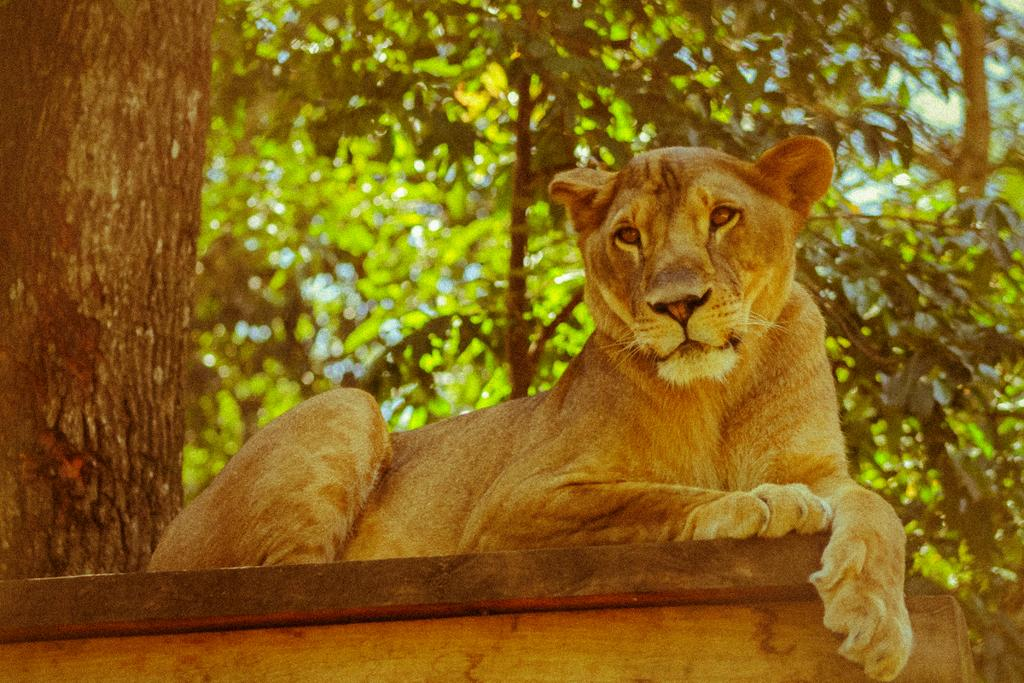What animal is the main subject of the image? There is a lion in the image. Where is the lion located in the image? The lion is on the floor. What can be seen in the background of the image? There are trees and the sky visible in the background of the image. What type of wrench is the lion using to fix the window in the image? There is no wrench or window present in the image; it features a lion on the floor with trees and a clear sky in the background. 